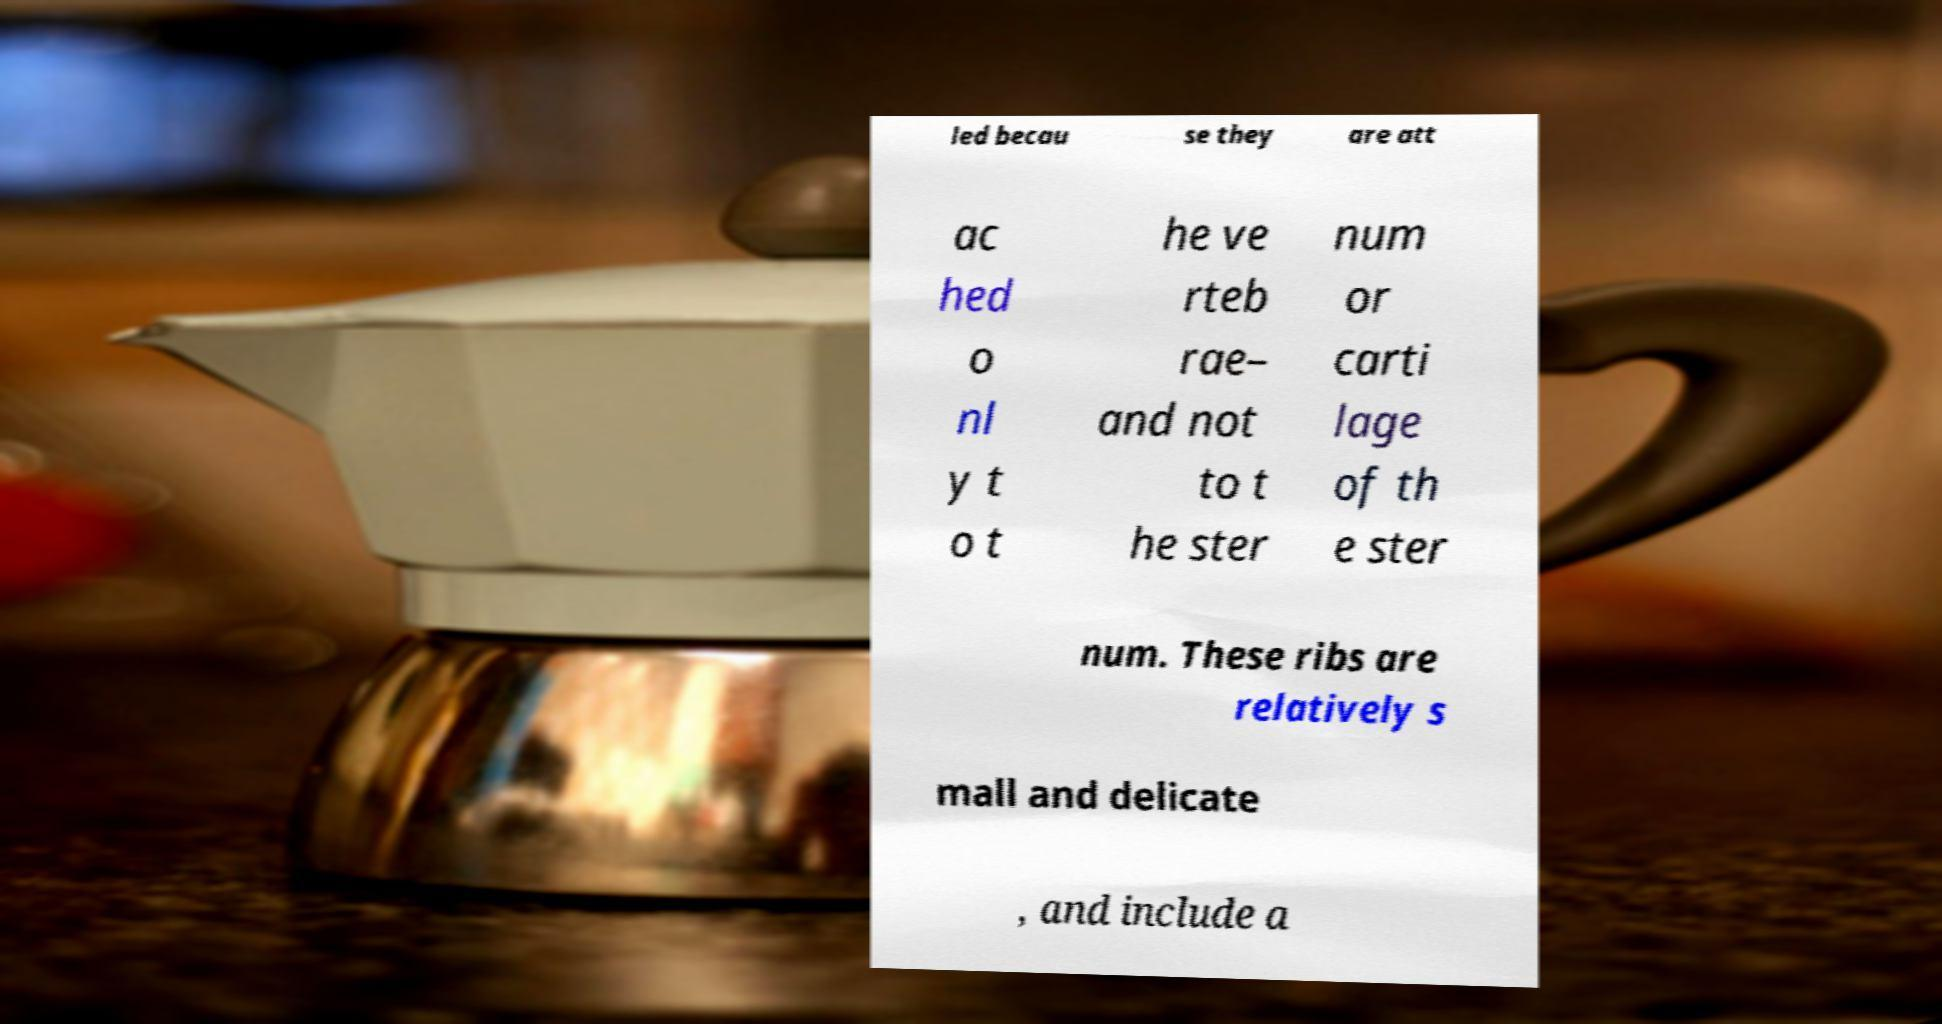Can you accurately transcribe the text from the provided image for me? led becau se they are att ac hed o nl y t o t he ve rteb rae– and not to t he ster num or carti lage of th e ster num. These ribs are relatively s mall and delicate , and include a 